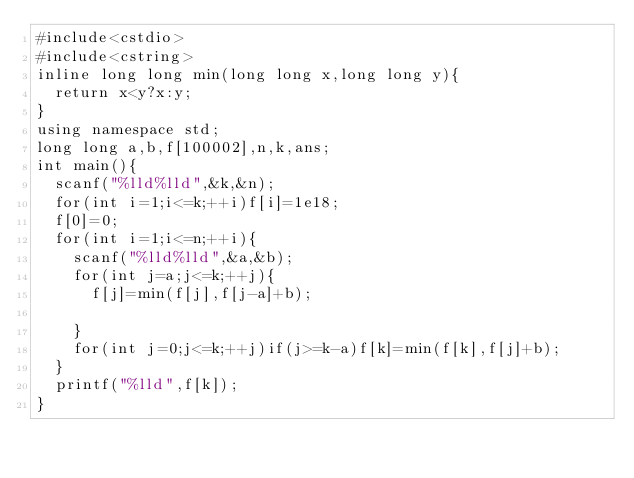Convert code to text. <code><loc_0><loc_0><loc_500><loc_500><_C++_>#include<cstdio>
#include<cstring>
inline long long min(long long x,long long y){
	return x<y?x:y;
}
using namespace std;
long long a,b,f[100002],n,k,ans;
int main(){
	scanf("%lld%lld",&k,&n);
	for(int i=1;i<=k;++i)f[i]=1e18;
	f[0]=0;
	for(int i=1;i<=n;++i){
		scanf("%lld%lld",&a,&b);
		for(int j=a;j<=k;++j){
			f[j]=min(f[j],f[j-a]+b);
			
		}
		for(int j=0;j<=k;++j)if(j>=k-a)f[k]=min(f[k],f[j]+b);
	}
	printf("%lld",f[k]);
}

</code> 